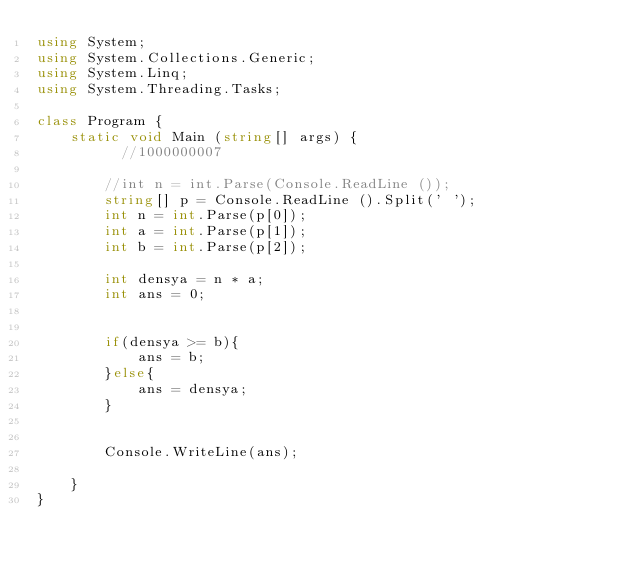<code> <loc_0><loc_0><loc_500><loc_500><_C#_>using System;
using System.Collections.Generic;
using System.Linq;
using System.Threading.Tasks;

class Program {
    static void Main (string[] args) {
          //1000000007

        //int n = int.Parse(Console.ReadLine ());
        string[] p = Console.ReadLine ().Split(' ');
        int n = int.Parse(p[0]);
        int a = int.Parse(p[1]);
        int b = int.Parse(p[2]);
        
        int densya = n * a;
        int ans = 0;


        if(densya >= b){
            ans = b;
        }else{
            ans = densya;
        }


        Console.WriteLine(ans);

    }
}</code> 